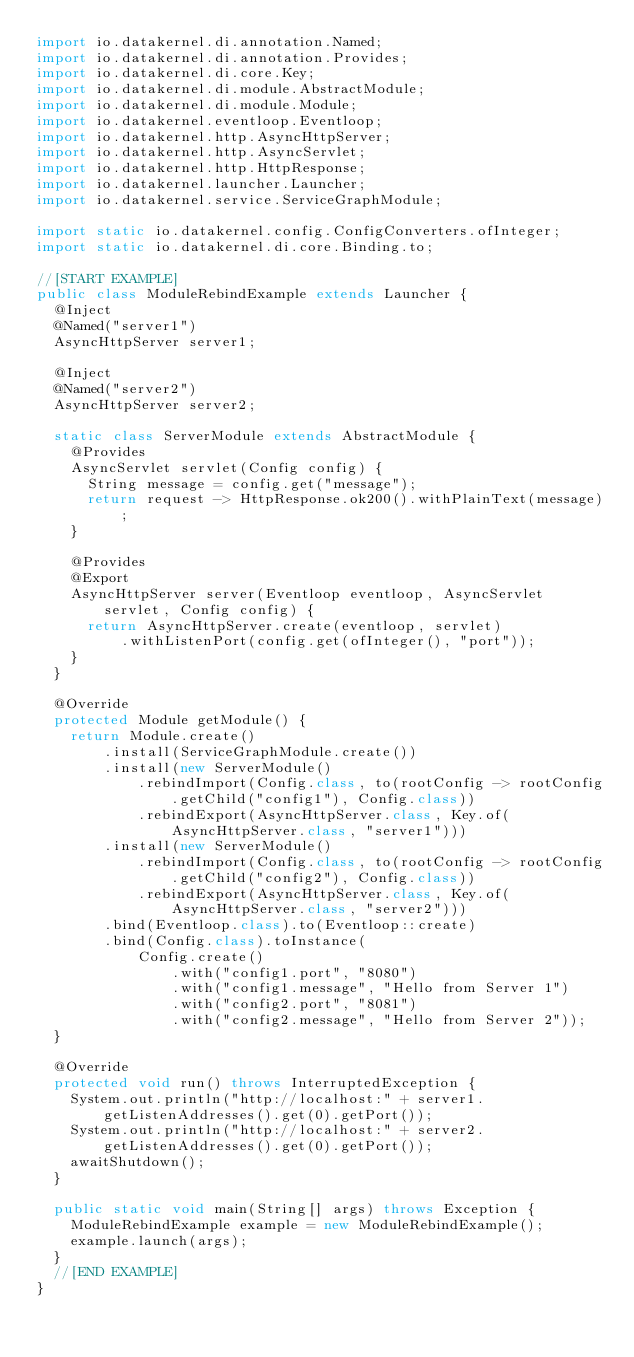<code> <loc_0><loc_0><loc_500><loc_500><_Java_>import io.datakernel.di.annotation.Named;
import io.datakernel.di.annotation.Provides;
import io.datakernel.di.core.Key;
import io.datakernel.di.module.AbstractModule;
import io.datakernel.di.module.Module;
import io.datakernel.eventloop.Eventloop;
import io.datakernel.http.AsyncHttpServer;
import io.datakernel.http.AsyncServlet;
import io.datakernel.http.HttpResponse;
import io.datakernel.launcher.Launcher;
import io.datakernel.service.ServiceGraphModule;

import static io.datakernel.config.ConfigConverters.ofInteger;
import static io.datakernel.di.core.Binding.to;

//[START EXAMPLE]
public class ModuleRebindExample extends Launcher {
	@Inject
	@Named("server1")
	AsyncHttpServer server1;

	@Inject
	@Named("server2")
	AsyncHttpServer server2;

	static class ServerModule extends AbstractModule {
		@Provides
		AsyncServlet servlet(Config config) {
			String message = config.get("message");
			return request -> HttpResponse.ok200().withPlainText(message);
		}

		@Provides
		@Export
		AsyncHttpServer server(Eventloop eventloop, AsyncServlet servlet, Config config) {
			return AsyncHttpServer.create(eventloop, servlet)
					.withListenPort(config.get(ofInteger(), "port"));
		}
	}

	@Override
	protected Module getModule() {
		return Module.create()
				.install(ServiceGraphModule.create())
				.install(new ServerModule()
						.rebindImport(Config.class, to(rootConfig -> rootConfig.getChild("config1"), Config.class))
						.rebindExport(AsyncHttpServer.class, Key.of(AsyncHttpServer.class, "server1")))
				.install(new ServerModule()
						.rebindImport(Config.class, to(rootConfig -> rootConfig.getChild("config2"), Config.class))
						.rebindExport(AsyncHttpServer.class, Key.of(AsyncHttpServer.class, "server2")))
				.bind(Eventloop.class).to(Eventloop::create)
				.bind(Config.class).toInstance(
						Config.create()
								.with("config1.port", "8080")
								.with("config1.message", "Hello from Server 1")
								.with("config2.port", "8081")
								.with("config2.message", "Hello from Server 2"));
	}

	@Override
	protected void run() throws InterruptedException {
		System.out.println("http://localhost:" + server1.getListenAddresses().get(0).getPort());
		System.out.println("http://localhost:" + server2.getListenAddresses().get(0).getPort());
		awaitShutdown();
	}

	public static void main(String[] args) throws Exception {
		ModuleRebindExample example = new ModuleRebindExample();
		example.launch(args);
	}
	//[END EXAMPLE]
}
</code> 